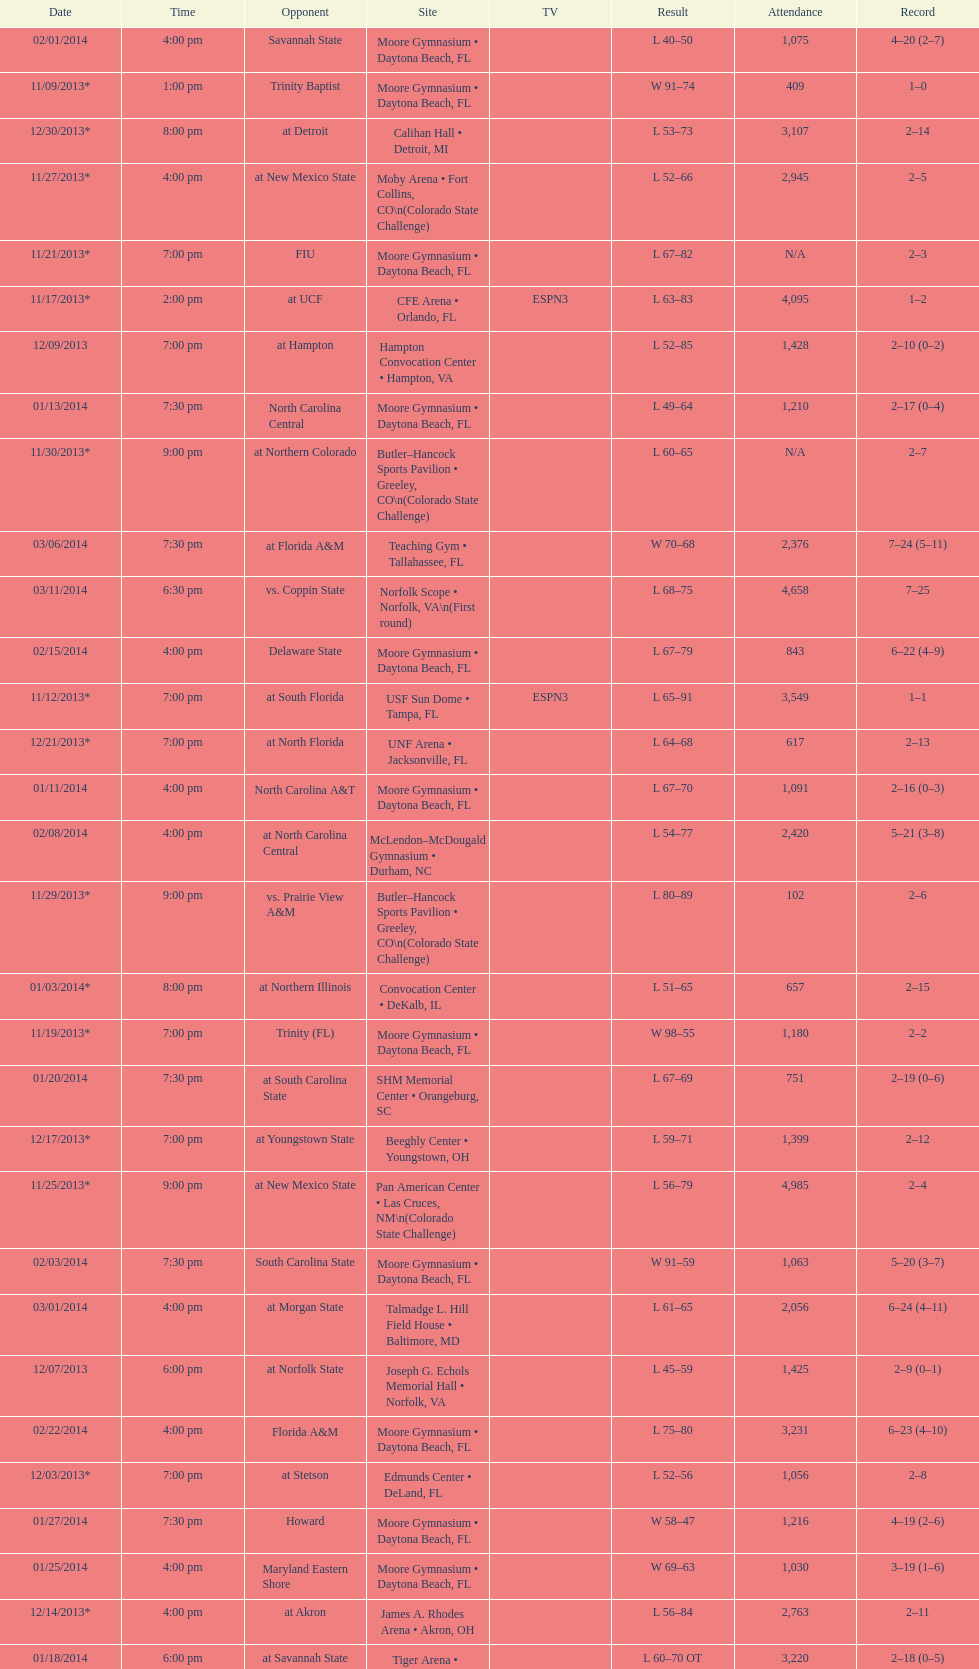Write the full table. {'header': ['Date', 'Time', 'Opponent', 'Site', 'TV', 'Result', 'Attendance', 'Record'], 'rows': [['02/01/2014', '4:00 pm', 'Savannah State', 'Moore Gymnasium • Daytona Beach, FL', '', 'L\xa040–50', '1,075', '4–20 (2–7)'], ['11/09/2013*', '1:00 pm', 'Trinity Baptist', 'Moore Gymnasium • Daytona Beach, FL', '', 'W\xa091–74', '409', '1–0'], ['12/30/2013*', '8:00 pm', 'at\xa0Detroit', 'Calihan Hall • Detroit, MI', '', 'L\xa053–73', '3,107', '2–14'], ['11/27/2013*', '4:00 pm', 'at\xa0New Mexico State', 'Moby Arena • Fort Collins, CO\\n(Colorado State Challenge)', '', 'L\xa052–66', '2,945', '2–5'], ['11/21/2013*', '7:00 pm', 'FIU', 'Moore Gymnasium • Daytona Beach, FL', '', 'L\xa067–82', 'N/A', '2–3'], ['11/17/2013*', '2:00 pm', 'at\xa0UCF', 'CFE Arena • Orlando, FL', 'ESPN3', 'L\xa063–83', '4,095', '1–2'], ['12/09/2013', '7:00 pm', 'at\xa0Hampton', 'Hampton Convocation Center • Hampton, VA', '', 'L\xa052–85', '1,428', '2–10 (0–2)'], ['01/13/2014', '7:30 pm', 'North Carolina Central', 'Moore Gymnasium • Daytona Beach, FL', '', 'L\xa049–64', '1,210', '2–17 (0–4)'], ['11/30/2013*', '9:00 pm', 'at\xa0Northern Colorado', 'Butler–Hancock Sports Pavilion • Greeley, CO\\n(Colorado State Challenge)', '', 'L\xa060–65', 'N/A', '2–7'], ['03/06/2014', '7:30 pm', 'at\xa0Florida A&M', 'Teaching Gym • Tallahassee, FL', '', 'W\xa070–68', '2,376', '7–24 (5–11)'], ['03/11/2014', '6:30 pm', 'vs.\xa0Coppin State', 'Norfolk Scope • Norfolk, VA\\n(First round)', '', 'L\xa068–75', '4,658', '7–25'], ['02/15/2014', '4:00 pm', 'Delaware State', 'Moore Gymnasium • Daytona Beach, FL', '', 'L\xa067–79', '843', '6–22 (4–9)'], ['11/12/2013*', '7:00 pm', 'at\xa0South Florida', 'USF Sun Dome • Tampa, FL', 'ESPN3', 'L\xa065–91', '3,549', '1–1'], ['12/21/2013*', '7:00 pm', 'at\xa0North Florida', 'UNF Arena • Jacksonville, FL', '', 'L\xa064–68', '617', '2–13'], ['01/11/2014', '4:00 pm', 'North Carolina A&T', 'Moore Gymnasium • Daytona Beach, FL', '', 'L\xa067–70', '1,091', '2–16 (0–3)'], ['02/08/2014', '4:00 pm', 'at\xa0North Carolina Central', 'McLendon–McDougald Gymnasium • Durham, NC', '', 'L\xa054–77', '2,420', '5–21 (3–8)'], ['11/29/2013*', '9:00 pm', 'vs.\xa0Prairie View A&M', 'Butler–Hancock Sports Pavilion • Greeley, CO\\n(Colorado State Challenge)', '', 'L\xa080–89', '102', '2–6'], ['01/03/2014*', '8:00 pm', 'at\xa0Northern Illinois', 'Convocation Center • DeKalb, IL', '', 'L\xa051–65', '657', '2–15'], ['11/19/2013*', '7:00 pm', 'Trinity (FL)', 'Moore Gymnasium • Daytona Beach, FL', '', 'W\xa098–55', '1,180', '2–2'], ['01/20/2014', '7:30 pm', 'at\xa0South Carolina State', 'SHM Memorial Center • Orangeburg, SC', '', 'L\xa067–69', '751', '2–19 (0–6)'], ['12/17/2013*', '7:00 pm', 'at\xa0Youngstown State', 'Beeghly Center • Youngstown, OH', '', 'L\xa059–71', '1,399', '2–12'], ['11/25/2013*', '9:00 pm', 'at\xa0New Mexico State', 'Pan American Center • Las Cruces, NM\\n(Colorado State Challenge)', '', 'L\xa056–79', '4,985', '2–4'], ['02/03/2014', '7:30 pm', 'South Carolina State', 'Moore Gymnasium • Daytona Beach, FL', '', 'W\xa091–59', '1,063', '5–20 (3–7)'], ['03/01/2014', '4:00 pm', 'at\xa0Morgan State', 'Talmadge L. Hill Field House • Baltimore, MD', '', 'L\xa061–65', '2,056', '6–24 (4–11)'], ['12/07/2013', '6:00 pm', 'at\xa0Norfolk State', 'Joseph G. Echols Memorial Hall • Norfolk, VA', '', 'L\xa045–59', '1,425', '2–9 (0–1)'], ['02/22/2014', '4:00 pm', 'Florida A&M', 'Moore Gymnasium • Daytona Beach, FL', '', 'L\xa075–80', '3,231', '6–23 (4–10)'], ['12/03/2013*', '7:00 pm', 'at\xa0Stetson', 'Edmunds Center • DeLand, FL', '', 'L\xa052–56', '1,056', '2–8'], ['01/27/2014', '7:30 pm', 'Howard', 'Moore Gymnasium • Daytona Beach, FL', '', 'W\xa058–47', '1,216', '4–19 (2–6)'], ['01/25/2014', '4:00 pm', 'Maryland Eastern Shore', 'Moore Gymnasium • Daytona Beach, FL', '', 'W\xa069–63', '1,030', '3–19 (1–6)'], ['12/14/2013*', '4:00 pm', 'at\xa0Akron', 'James A. Rhodes Arena • Akron, OH', '', 'L\xa056–84', '2,763', '2–11'], ['01/18/2014', '6:00 pm', 'at\xa0Savannah State', 'Tiger Arena • Savannah, GA', '', 'L\xa060–70\xa0OT', '3,220', '2–18 (0–5)'], ['02/10/2014', '8:00 pm', 'at\xa0North Carolina A&T', 'Corbett Sports Center • Greensboro, NC', '', 'W\xa072–71', '1,019', '6–21 (4–8)']]} How many games had more than 1,500 in attendance? 12. 